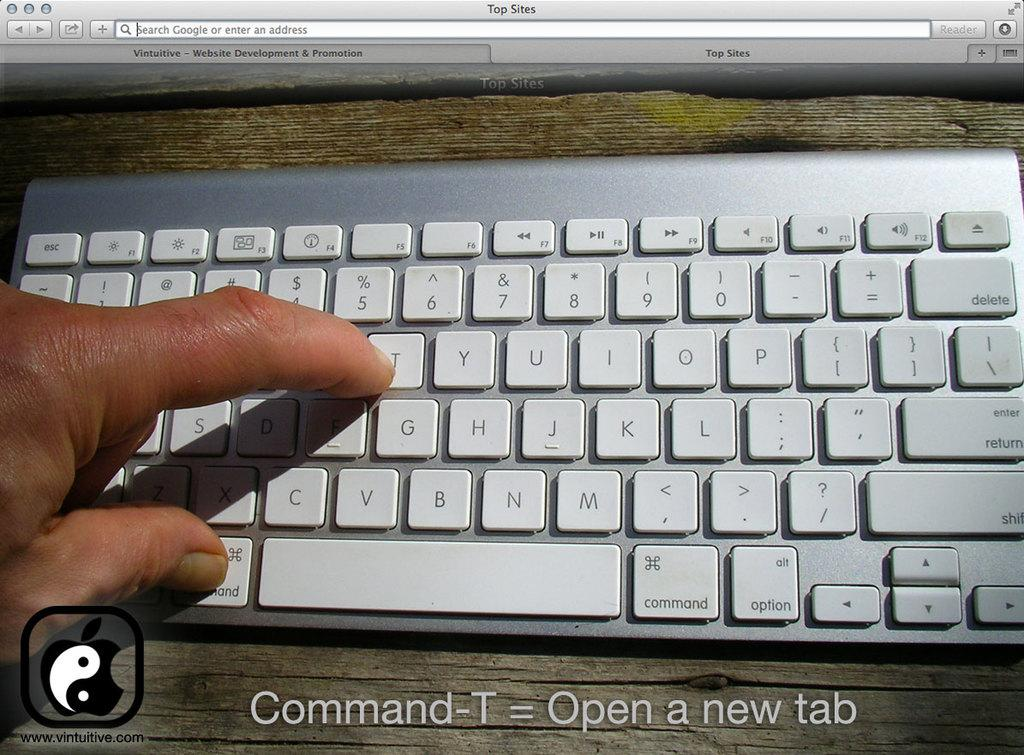<image>
Relay a brief, clear account of the picture shown. A person is pushing the letter T on a keyboard. 